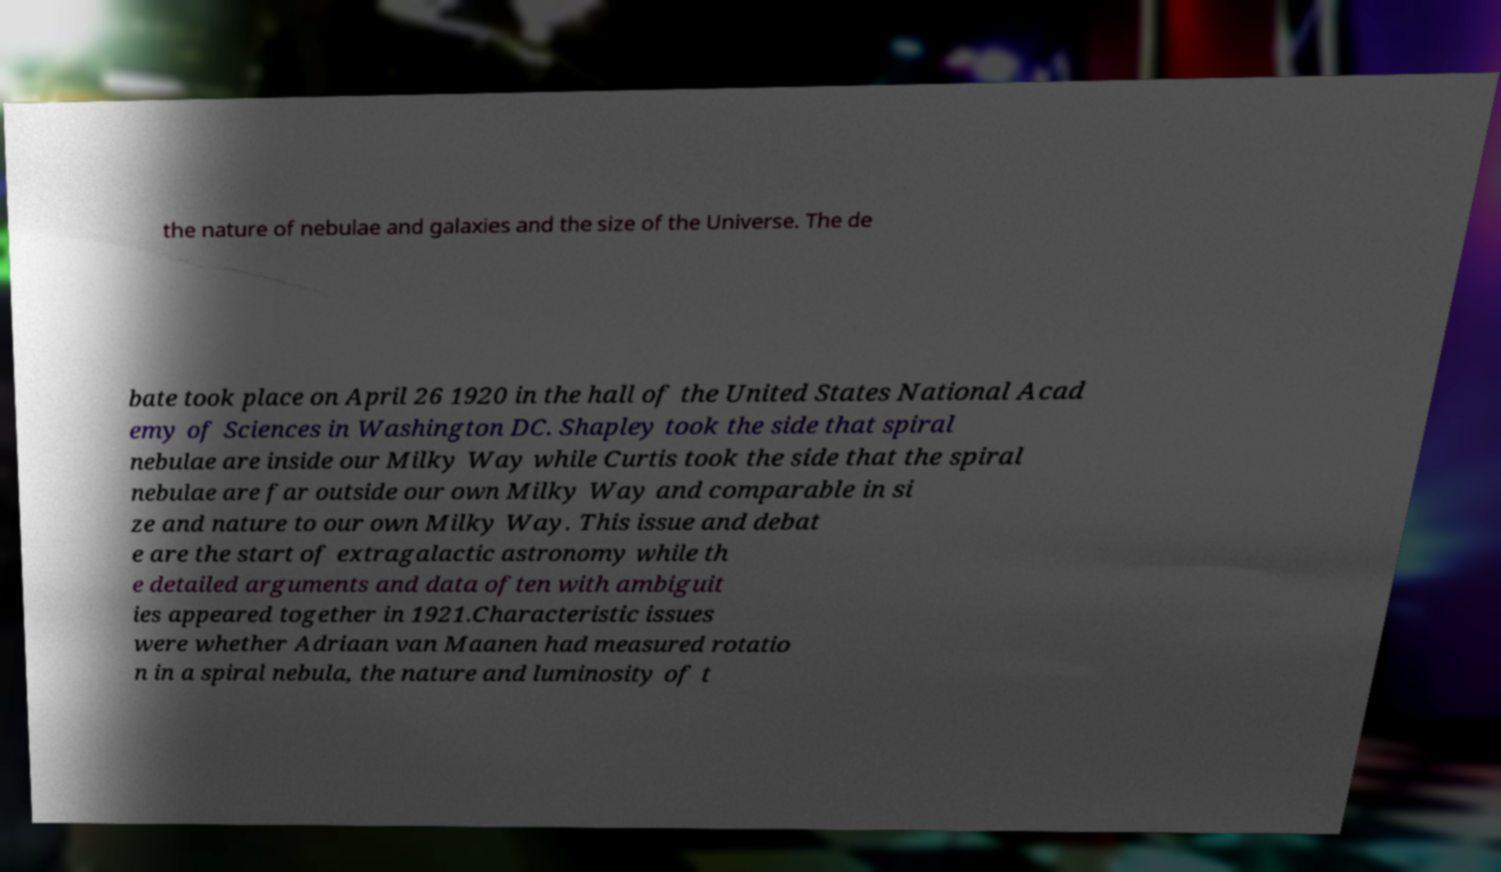Can you read and provide the text displayed in the image?This photo seems to have some interesting text. Can you extract and type it out for me? the nature of nebulae and galaxies and the size of the Universe. The de bate took place on April 26 1920 in the hall of the United States National Acad emy of Sciences in Washington DC. Shapley took the side that spiral nebulae are inside our Milky Way while Curtis took the side that the spiral nebulae are far outside our own Milky Way and comparable in si ze and nature to our own Milky Way. This issue and debat e are the start of extragalactic astronomy while th e detailed arguments and data often with ambiguit ies appeared together in 1921.Characteristic issues were whether Adriaan van Maanen had measured rotatio n in a spiral nebula, the nature and luminosity of t 